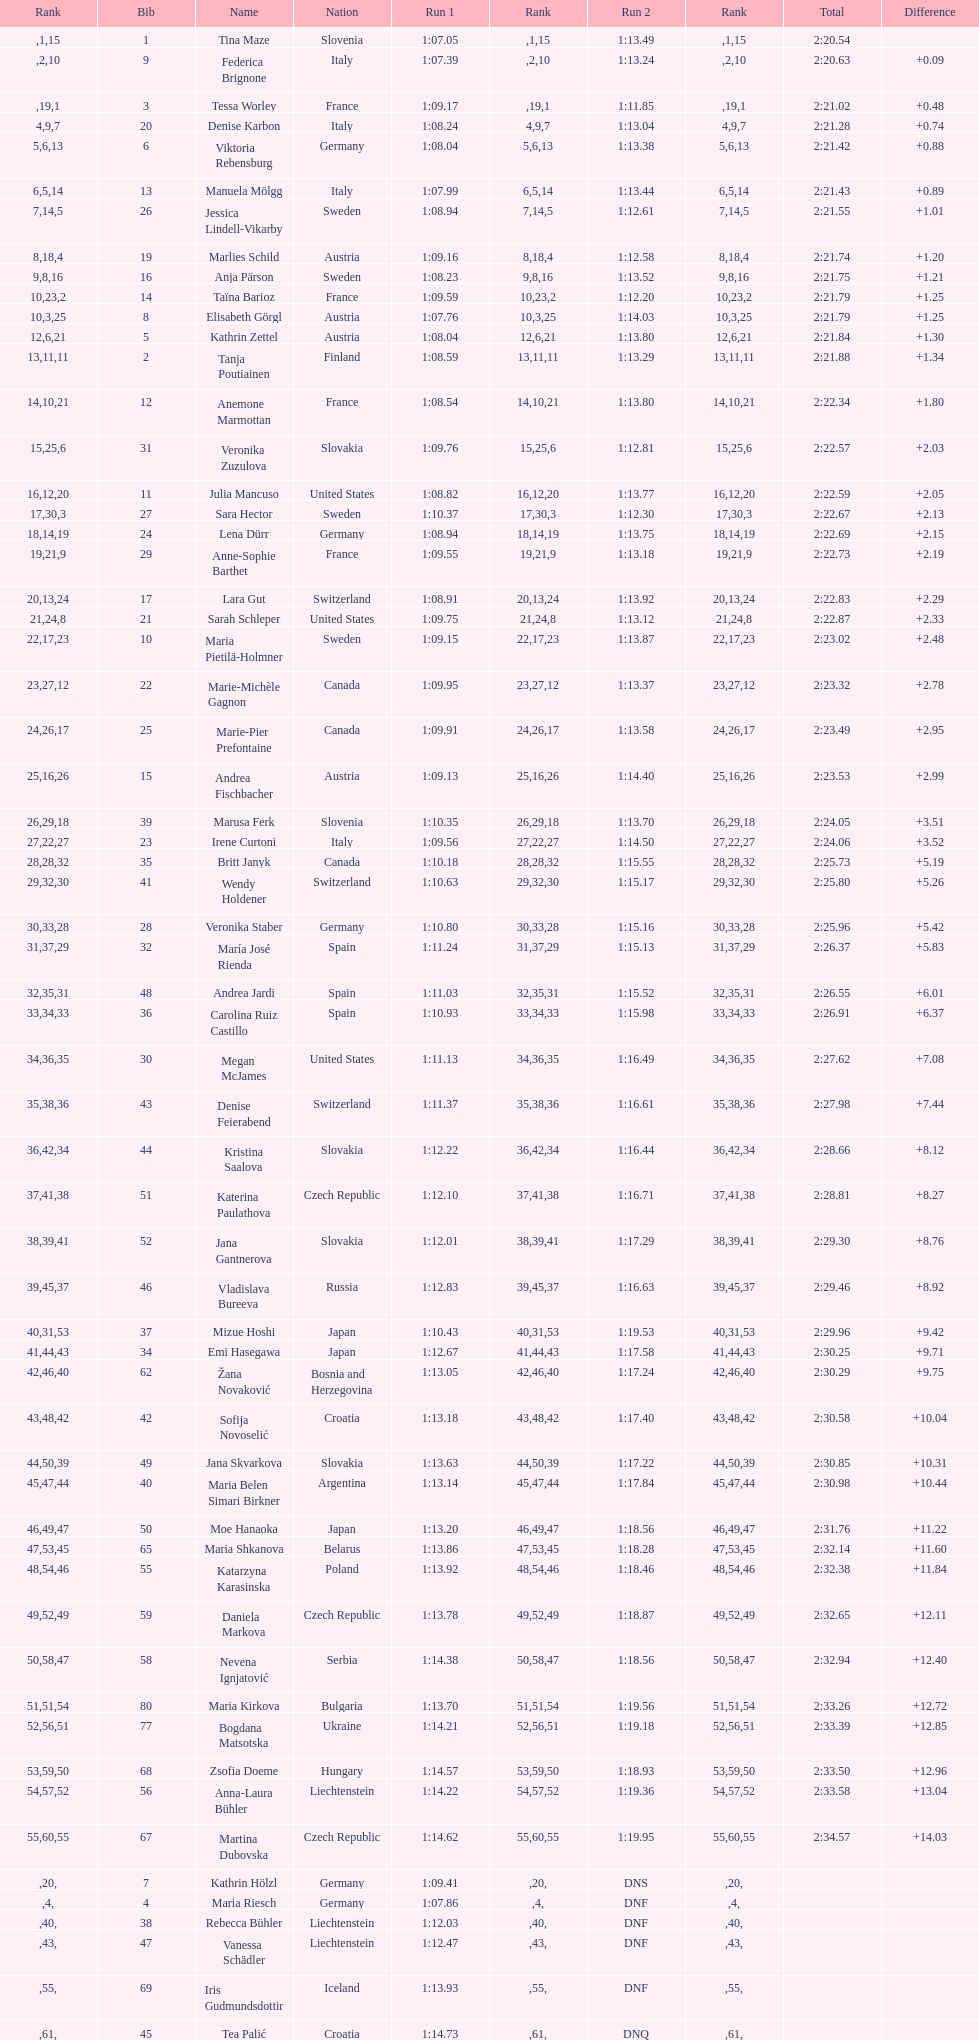How many italians finished in the top ten? 3. 